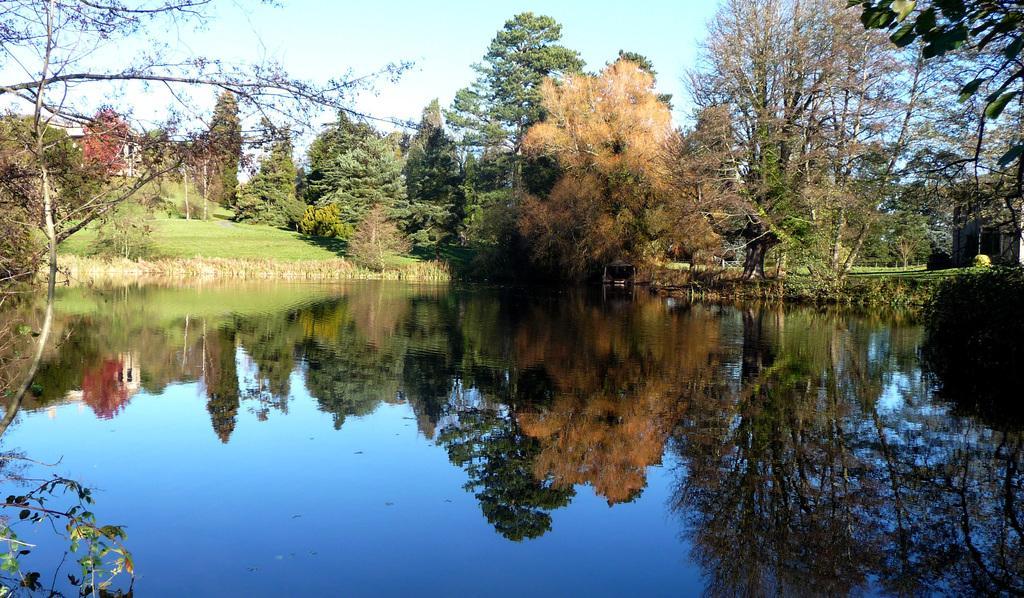Can you describe this image briefly? In this image I can see the water, few trees which are green, brown and red in color, a house and in the background I can see the sky. 